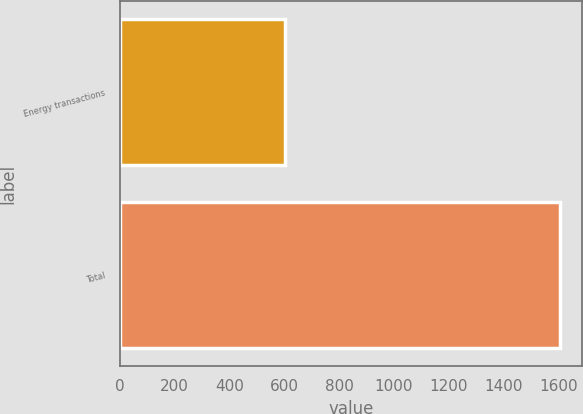Convert chart. <chart><loc_0><loc_0><loc_500><loc_500><bar_chart><fcel>Energy transactions<fcel>Total<nl><fcel>603<fcel>1605<nl></chart> 